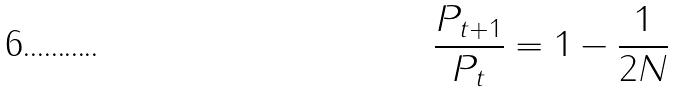Convert formula to latex. <formula><loc_0><loc_0><loc_500><loc_500>\frac { P _ { t + 1 } } { P _ { t } } = 1 - \frac { 1 } { 2 N }</formula> 